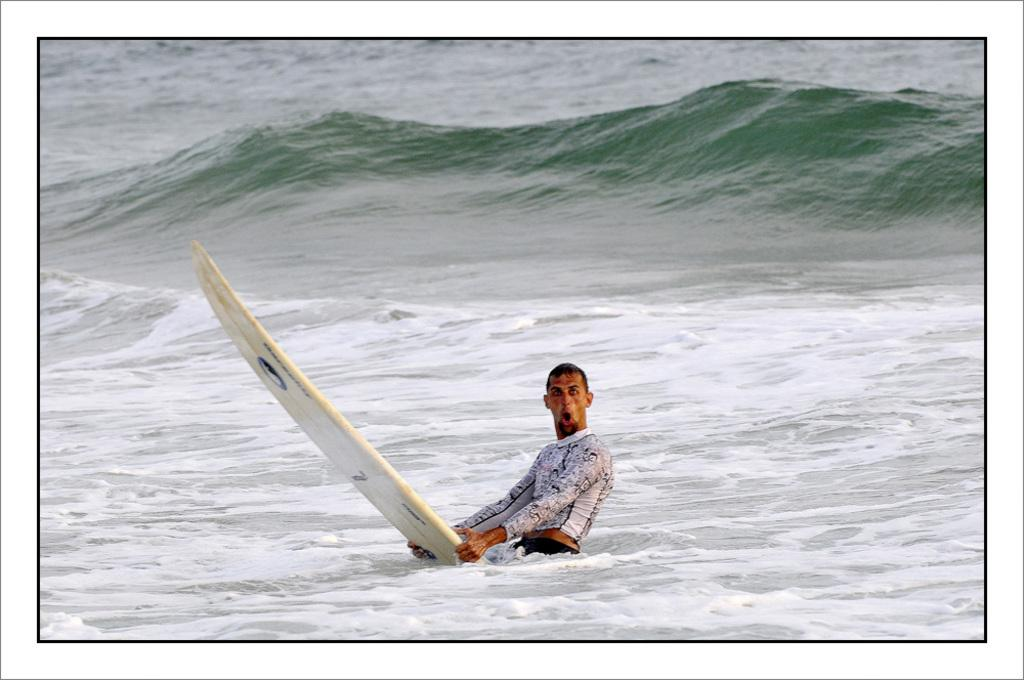What is the main subject of the image? The main subject of the image is a man. What is the man doing in the image? The man is surfing in the water. What type of authority does the man have in the image? There is no indication of any authority figure in the image; it simply shows a man surfing in the water. How many birds can be seen flying in the image? There are no birds visible in the image; it features a man surfing in the water. 